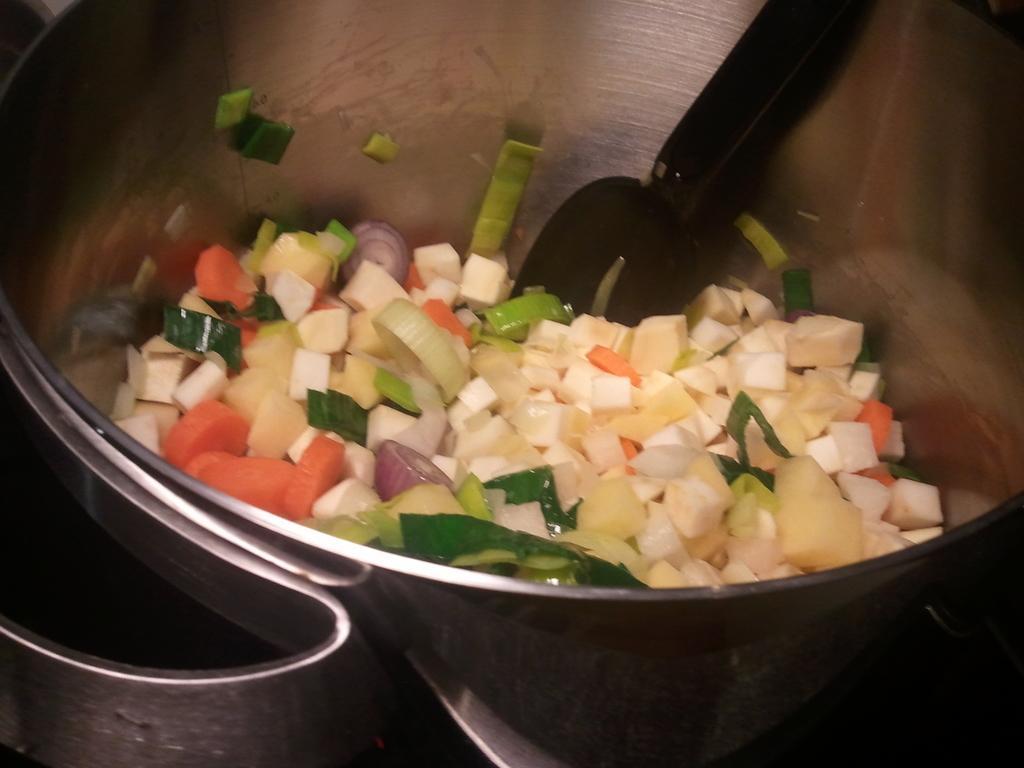Could you give a brief overview of what you see in this image? In this image, we can see a food and spoon are in the steel bowl. 